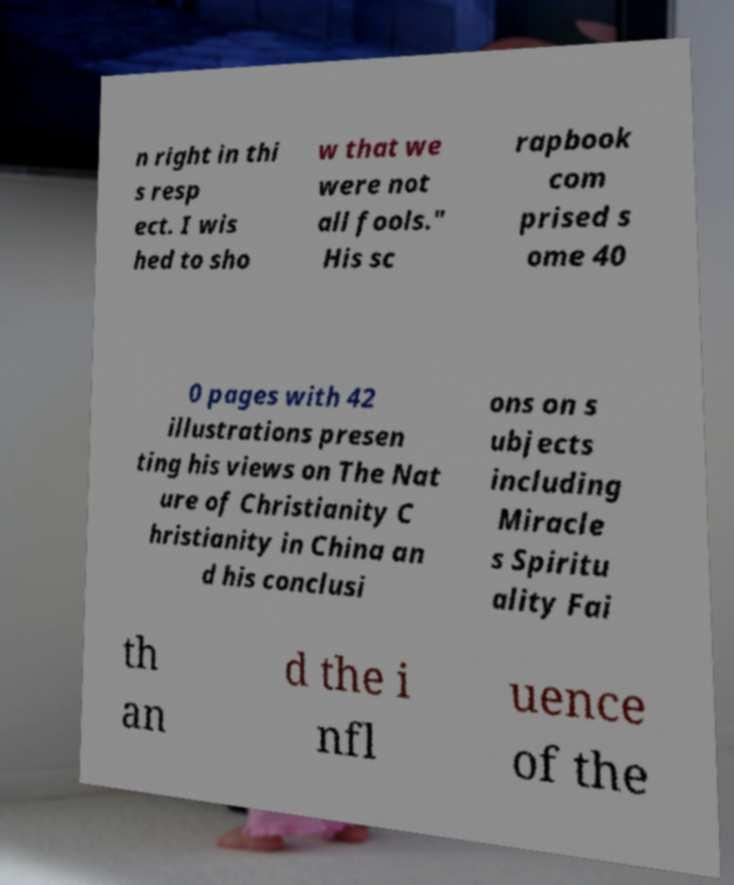Please identify and transcribe the text found in this image. n right in thi s resp ect. I wis hed to sho w that we were not all fools." His sc rapbook com prised s ome 40 0 pages with 42 illustrations presen ting his views on The Nat ure of Christianity C hristianity in China an d his conclusi ons on s ubjects including Miracle s Spiritu ality Fai th an d the i nfl uence of the 